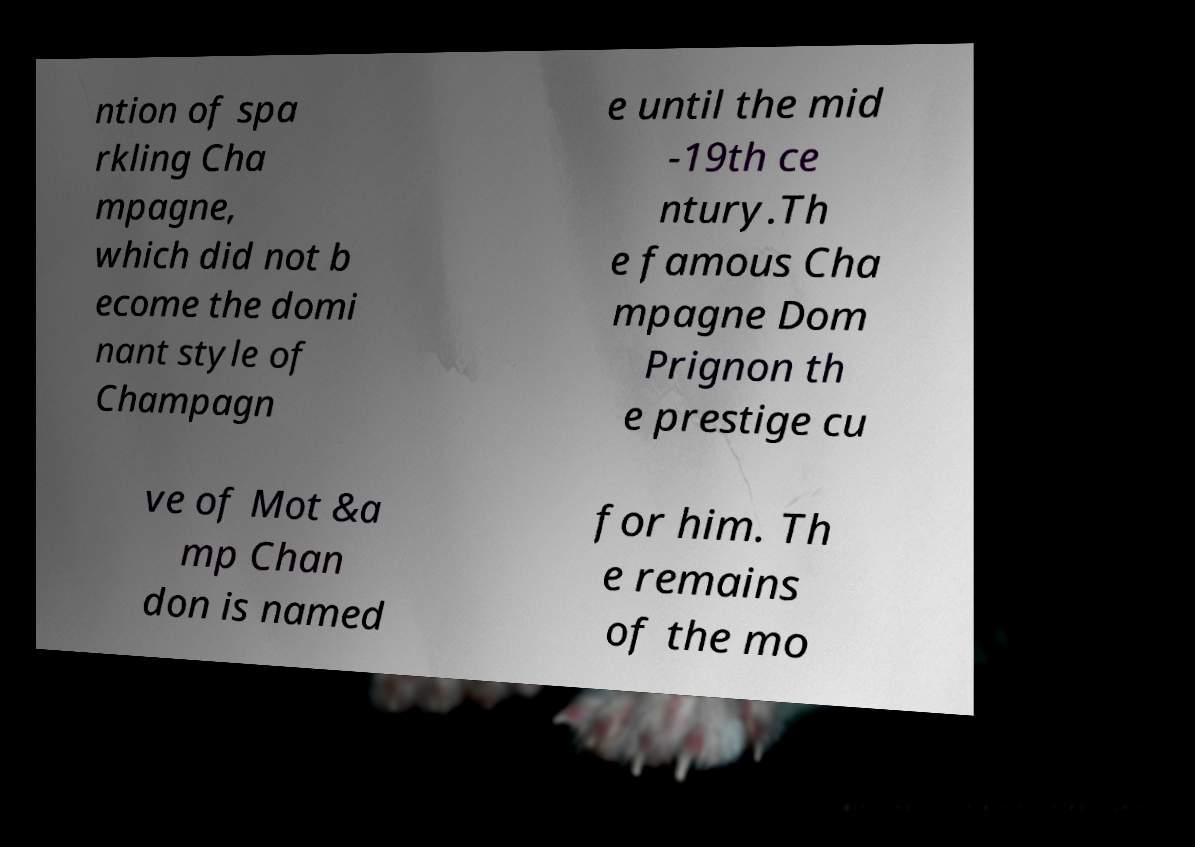There's text embedded in this image that I need extracted. Can you transcribe it verbatim? ntion of spa rkling Cha mpagne, which did not b ecome the domi nant style of Champagn e until the mid -19th ce ntury.Th e famous Cha mpagne Dom Prignon th e prestige cu ve of Mot &a mp Chan don is named for him. Th e remains of the mo 